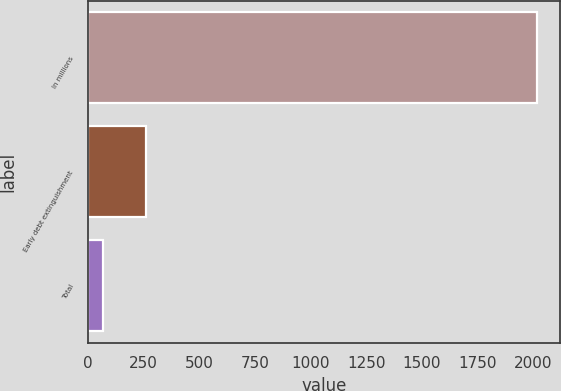<chart> <loc_0><loc_0><loc_500><loc_500><bar_chart><fcel>In millions<fcel>Early debt extinguishment<fcel>Total<nl><fcel>2017<fcel>262<fcel>67<nl></chart> 